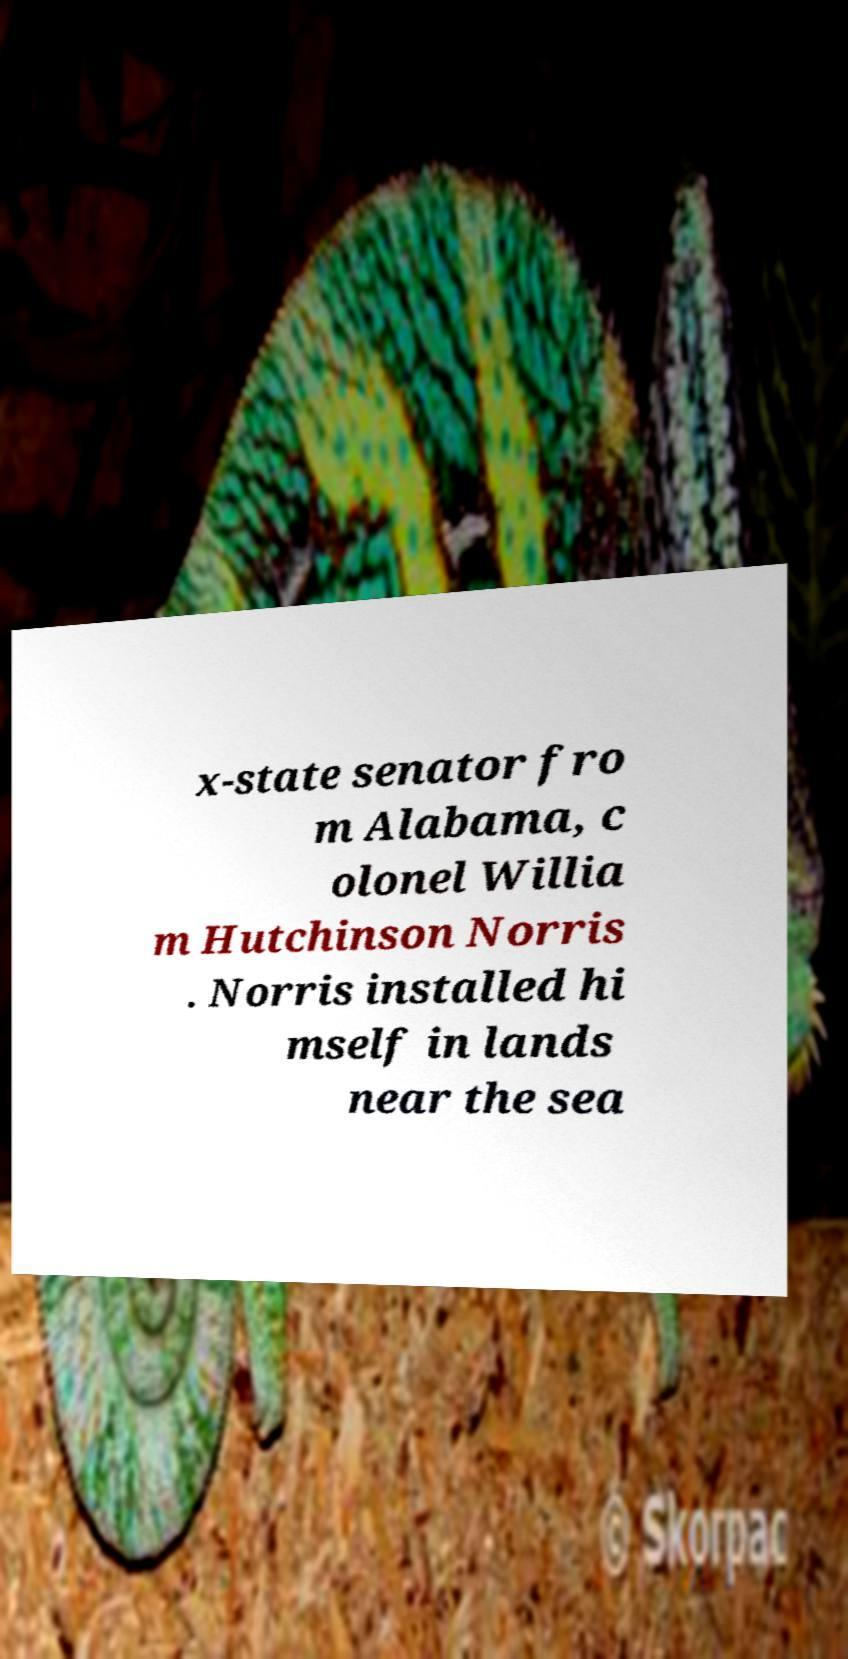For documentation purposes, I need the text within this image transcribed. Could you provide that? x-state senator fro m Alabama, c olonel Willia m Hutchinson Norris . Norris installed hi mself in lands near the sea 